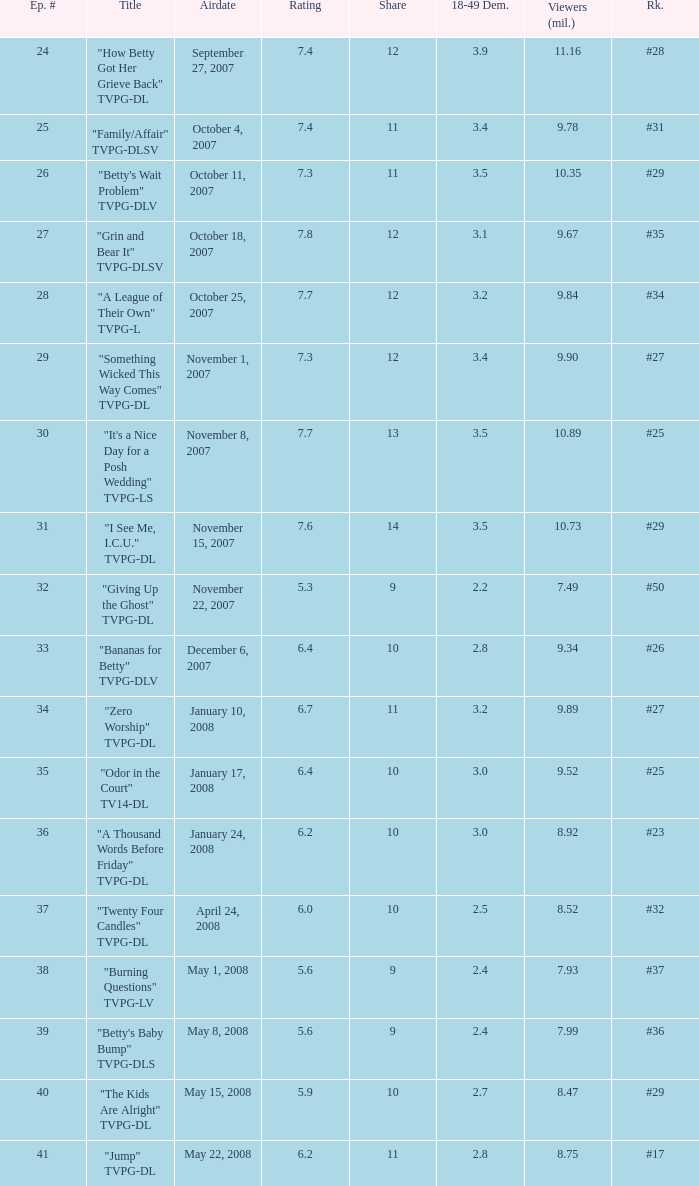What is the Airdate of the episode that ranked #29 and had a share greater than 10? May 15, 2008. 